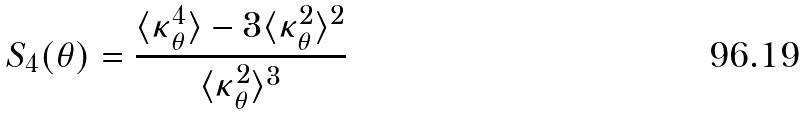<formula> <loc_0><loc_0><loc_500><loc_500>S _ { 4 } ( \theta ) = \frac { \langle \kappa _ { \theta } ^ { 4 } \rangle - 3 \langle \kappa _ { \theta } ^ { 2 } \rangle ^ { 2 } } { \langle \kappa _ { \theta } ^ { 2 } \rangle ^ { 3 } }</formula> 